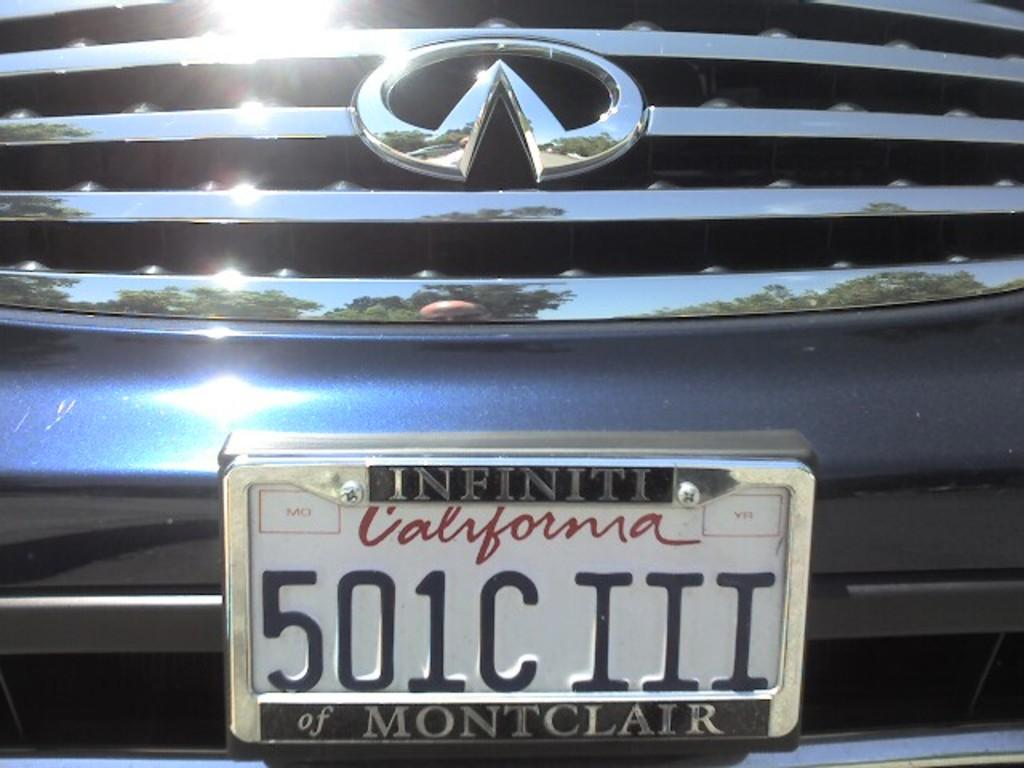<image>
Give a short and clear explanation of the subsequent image. A license plate made for a car in the state of California. 